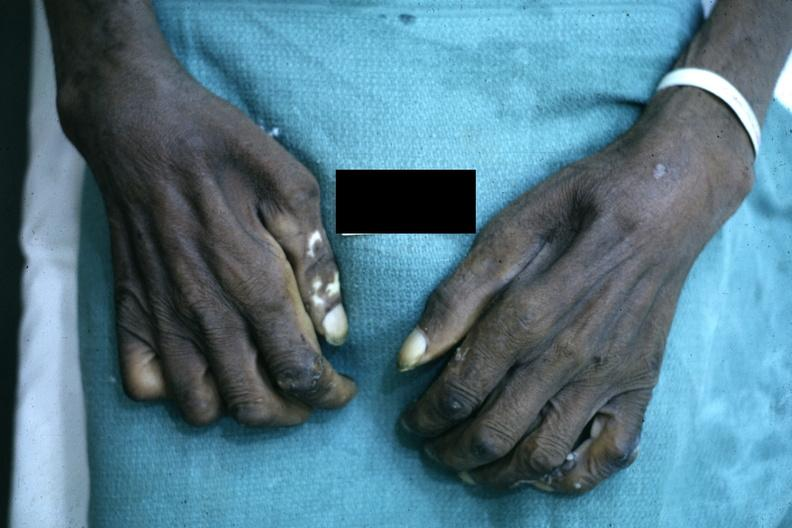does acid show close-up excellent example of interosseous muscle atrophy said to be due to syringomyelus?
Answer the question using a single word or phrase. No 